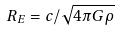Convert formula to latex. <formula><loc_0><loc_0><loc_500><loc_500>R _ { E } = c / \sqrt { 4 \pi G \rho }</formula> 